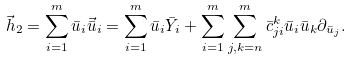Convert formula to latex. <formula><loc_0><loc_0><loc_500><loc_500>\vec { h } _ { 2 } = \sum _ { i = 1 } ^ { m } \bar { u } _ { i } \vec { \bar { u } } _ { i } = \sum _ { i = 1 } ^ { m } \bar { u } _ { i } \bar { Y } _ { i } + \sum _ { i = 1 } ^ { m } \sum _ { j , k = n } ^ { m } \bar { c } _ { j i } ^ { k } \bar { u } _ { i } \bar { u } _ { k } \partial _ { \bar { u } _ { j } } .</formula> 